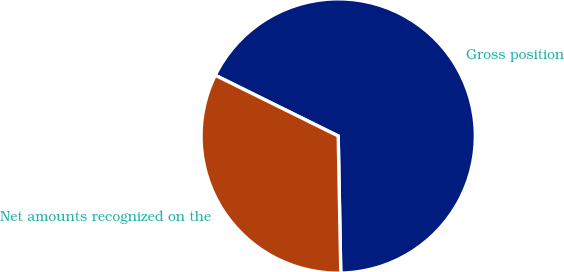Convert chart to OTSL. <chart><loc_0><loc_0><loc_500><loc_500><pie_chart><fcel>Gross position<fcel>Net amounts recognized on the<nl><fcel>67.4%<fcel>32.6%<nl></chart> 